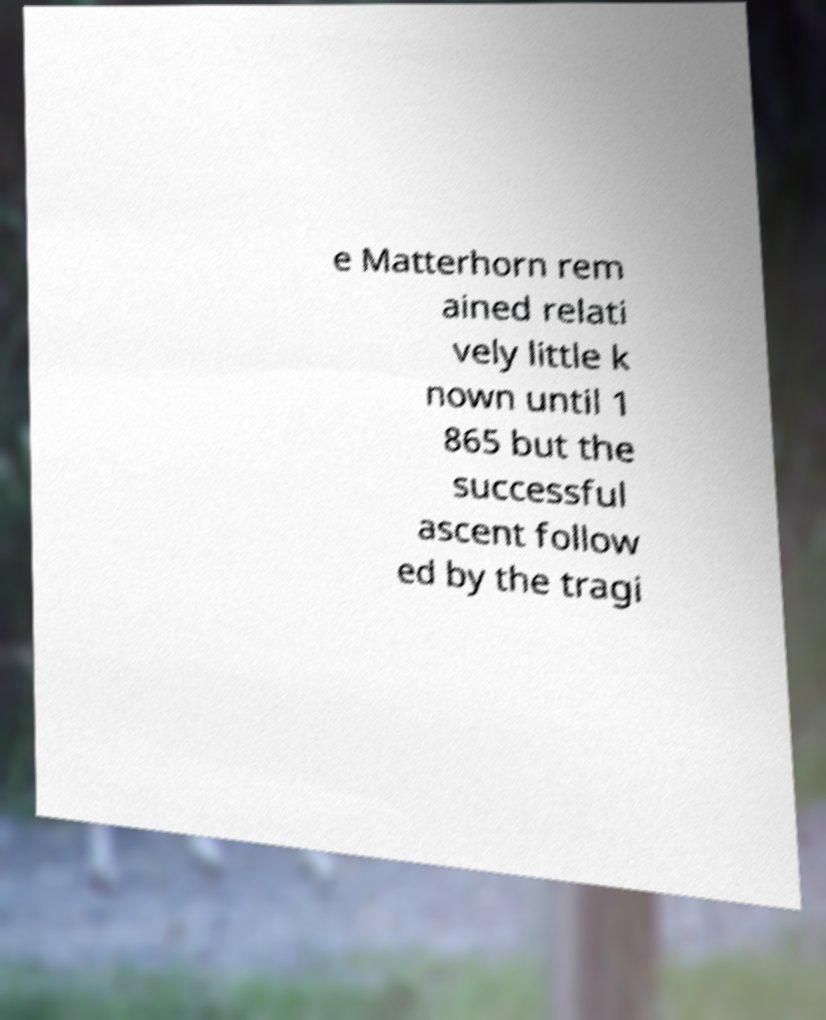Can you accurately transcribe the text from the provided image for me? e Matterhorn rem ained relati vely little k nown until 1 865 but the successful ascent follow ed by the tragi 